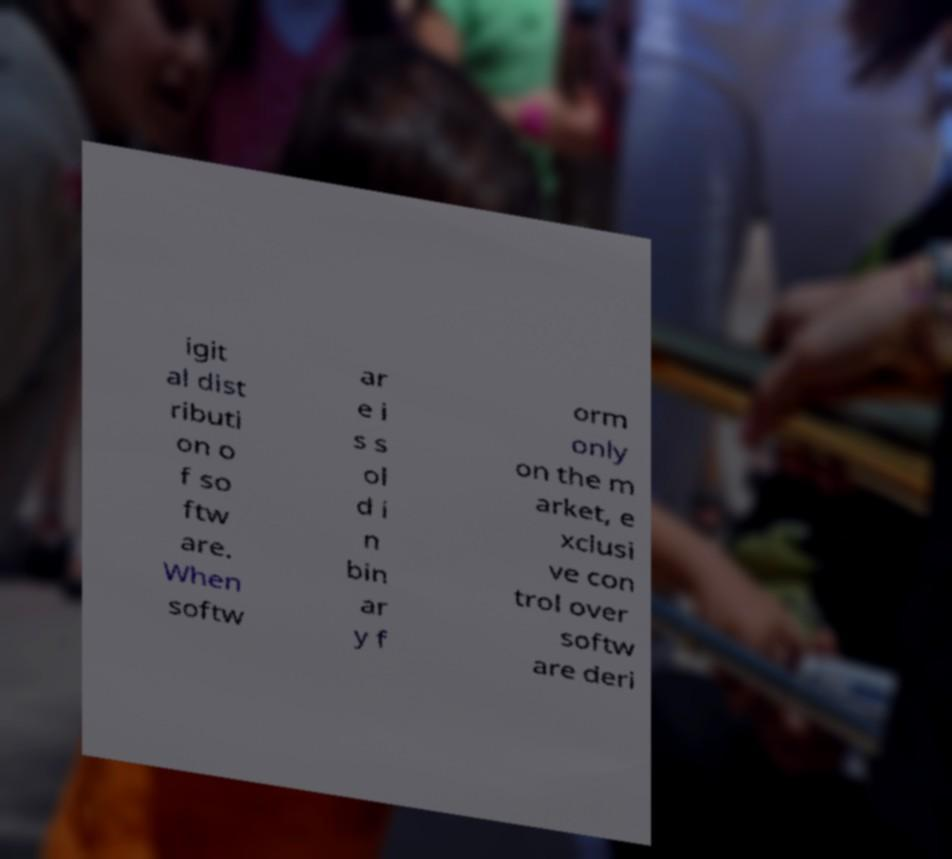Can you read and provide the text displayed in the image?This photo seems to have some interesting text. Can you extract and type it out for me? igit al dist ributi on o f so ftw are. When softw ar e i s s ol d i n bin ar y f orm only on the m arket, e xclusi ve con trol over softw are deri 